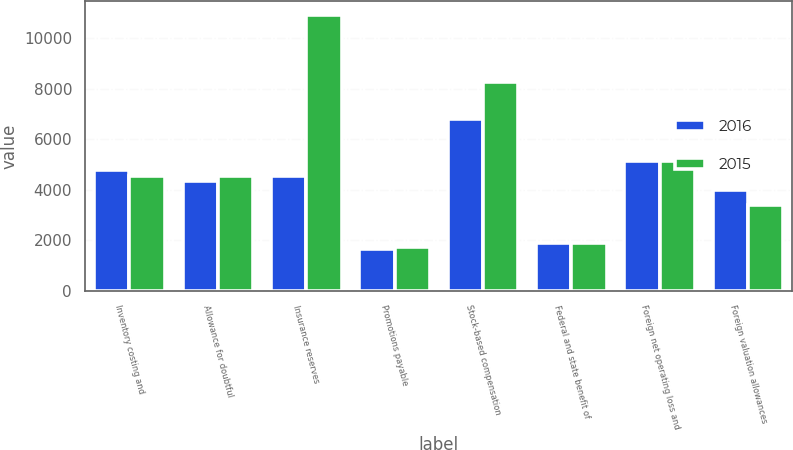Convert chart. <chart><loc_0><loc_0><loc_500><loc_500><stacked_bar_chart><ecel><fcel>Inventory costing and<fcel>Allowance for doubtful<fcel>Insurance reserves<fcel>Promotions payable<fcel>Stock-based compensation<fcel>Federal and state benefit of<fcel>Foreign net operating loss and<fcel>Foreign valuation allowances<nl><fcel>2016<fcel>4788<fcel>4339<fcel>4529<fcel>1651<fcel>6789<fcel>1908<fcel>5121<fcel>3998<nl><fcel>2015<fcel>4556<fcel>4529<fcel>10930<fcel>1738<fcel>8270<fcel>1911<fcel>5155<fcel>3406<nl></chart> 